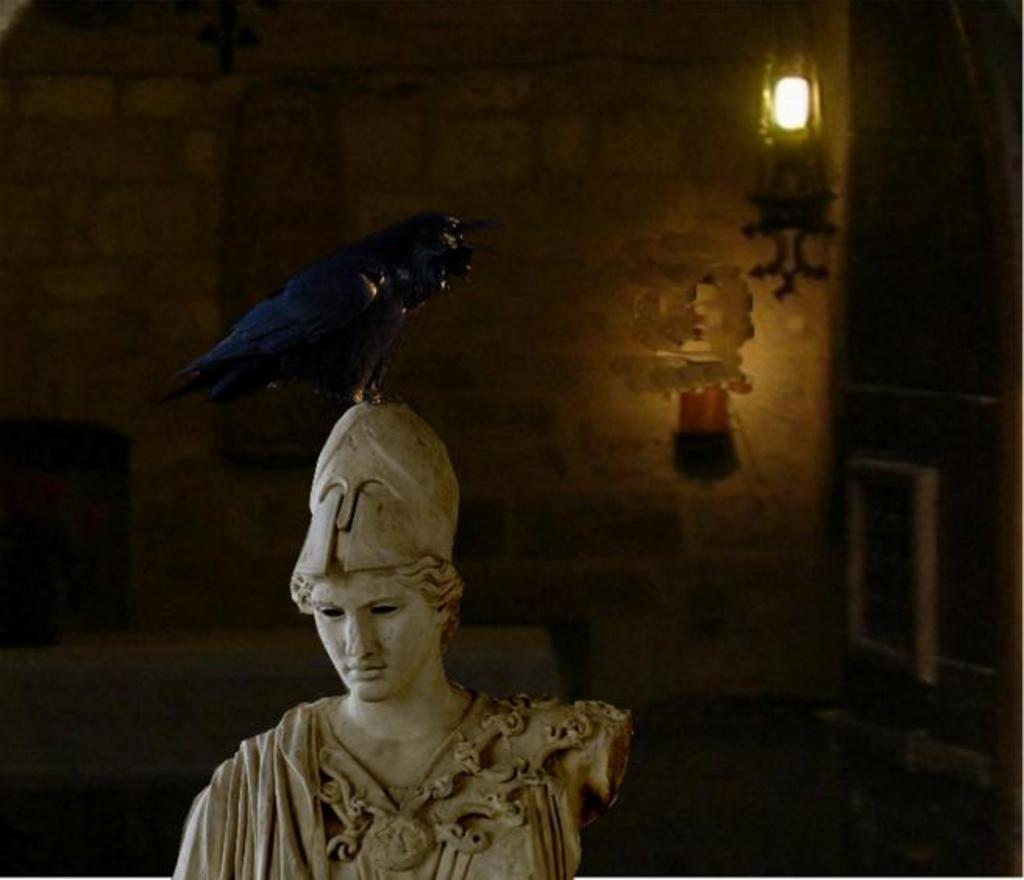What is on the sculpture in the image? There is a bird on the sculpture in the image. Where is the sculpture located in relation to other objects? The sculpture is beside a wall. What can be seen in the top right of the image? There is a light in the top right of the image. How many eggs did the bird lay on the sculpture in the image? There is no indication of eggs or any nesting activity in the image. 